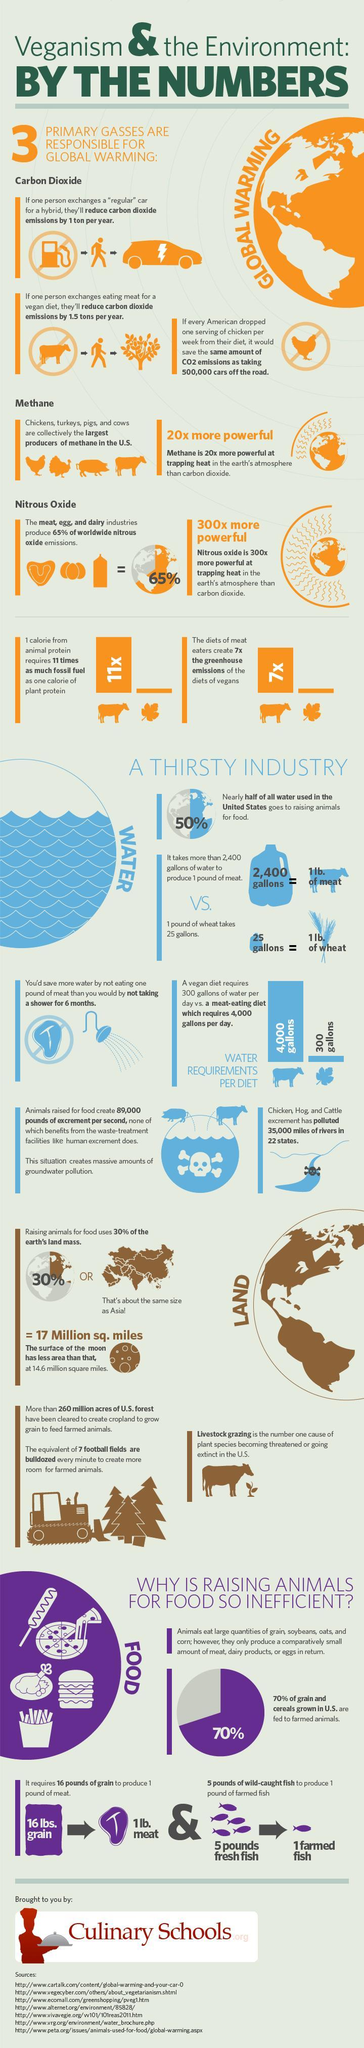Which gases are responsible for global warming?
Answer the question with a short phrase. Carbon Dioxide, Methane, Nitrous Oxide How many sources are listed at the bottom? 7 By what amount is water required per day by meat eaters higher than vegan dieters? 3,700 gallons 